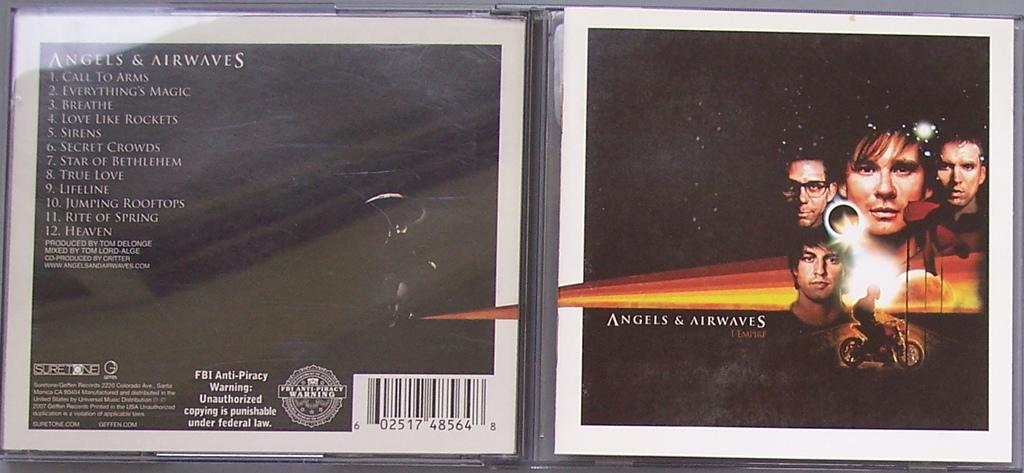<image>
Relay a brief, clear account of the picture shown. An open CD case that says Angels and Airwaves on the cover of it. 